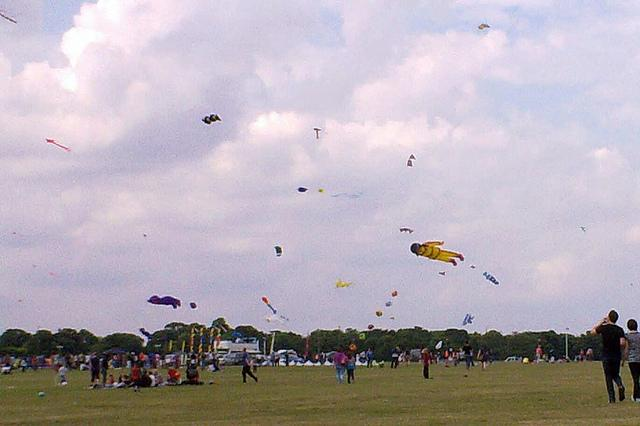What is the largest kite flying made to resemble? Please explain your reasoning. human. It has arms and legs with the same proportions as a human, which a mother, hummingbird, and cell phone do not have. 